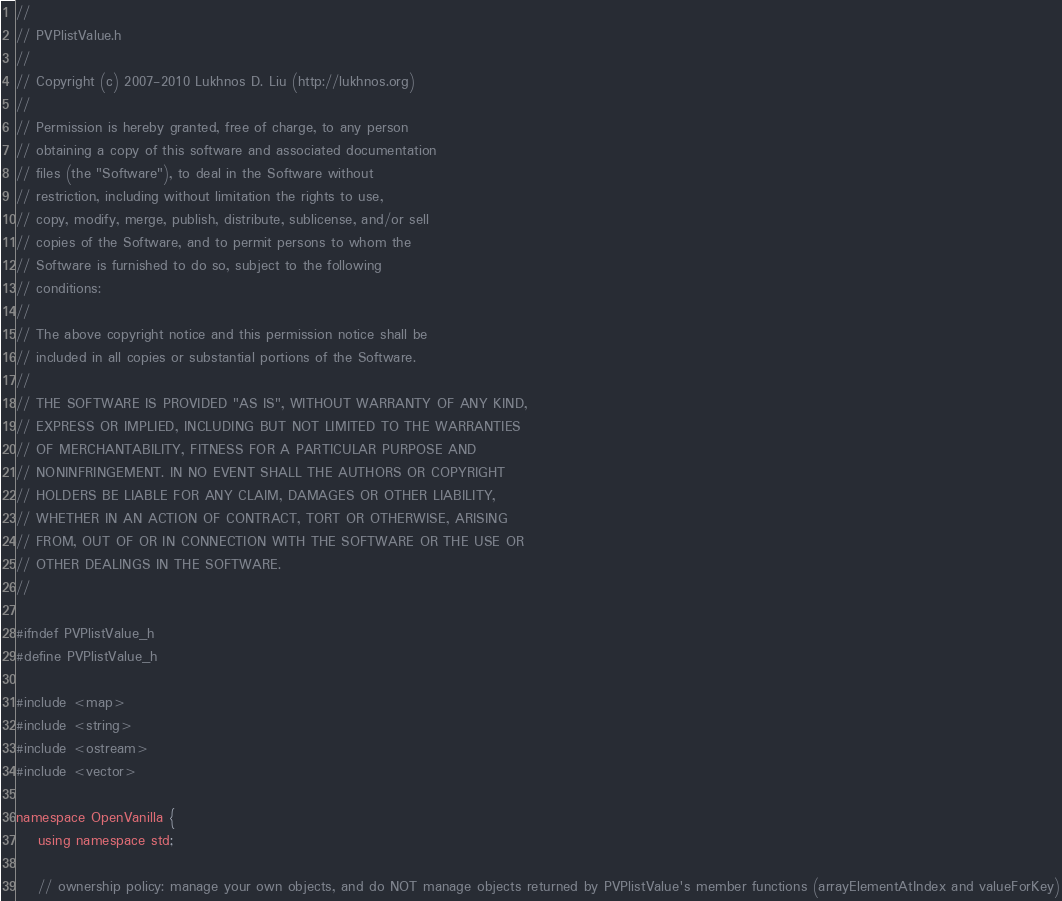<code> <loc_0><loc_0><loc_500><loc_500><_C_>//
// PVPlistValue.h
//
// Copyright (c) 2007-2010 Lukhnos D. Liu (http://lukhnos.org)
//
// Permission is hereby granted, free of charge, to any person
// obtaining a copy of this software and associated documentation
// files (the "Software"), to deal in the Software without
// restriction, including without limitation the rights to use,
// copy, modify, merge, publish, distribute, sublicense, and/or sell
// copies of the Software, and to permit persons to whom the
// Software is furnished to do so, subject to the following
// conditions:
//
// The above copyright notice and this permission notice shall be
// included in all copies or substantial portions of the Software.
//
// THE SOFTWARE IS PROVIDED "AS IS", WITHOUT WARRANTY OF ANY KIND,
// EXPRESS OR IMPLIED, INCLUDING BUT NOT LIMITED TO THE WARRANTIES
// OF MERCHANTABILITY, FITNESS FOR A PARTICULAR PURPOSE AND
// NONINFRINGEMENT. IN NO EVENT SHALL THE AUTHORS OR COPYRIGHT
// HOLDERS BE LIABLE FOR ANY CLAIM, DAMAGES OR OTHER LIABILITY,
// WHETHER IN AN ACTION OF CONTRACT, TORT OR OTHERWISE, ARISING
// FROM, OUT OF OR IN CONNECTION WITH THE SOFTWARE OR THE USE OR
// OTHER DEALINGS IN THE SOFTWARE.
//

#ifndef PVPlistValue_h
#define PVPlistValue_h

#include <map>
#include <string>
#include <ostream>
#include <vector>

namespace OpenVanilla {
    using namespace std;

    // ownership policy: manage your own objects, and do NOT manage objects returned by PVPlistValue's member functions (arrayElementAtIndex and valueForKey)</code> 